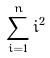Convert formula to latex. <formula><loc_0><loc_0><loc_500><loc_500>\sum _ { i = 1 } ^ { n } i ^ { 2 }</formula> 